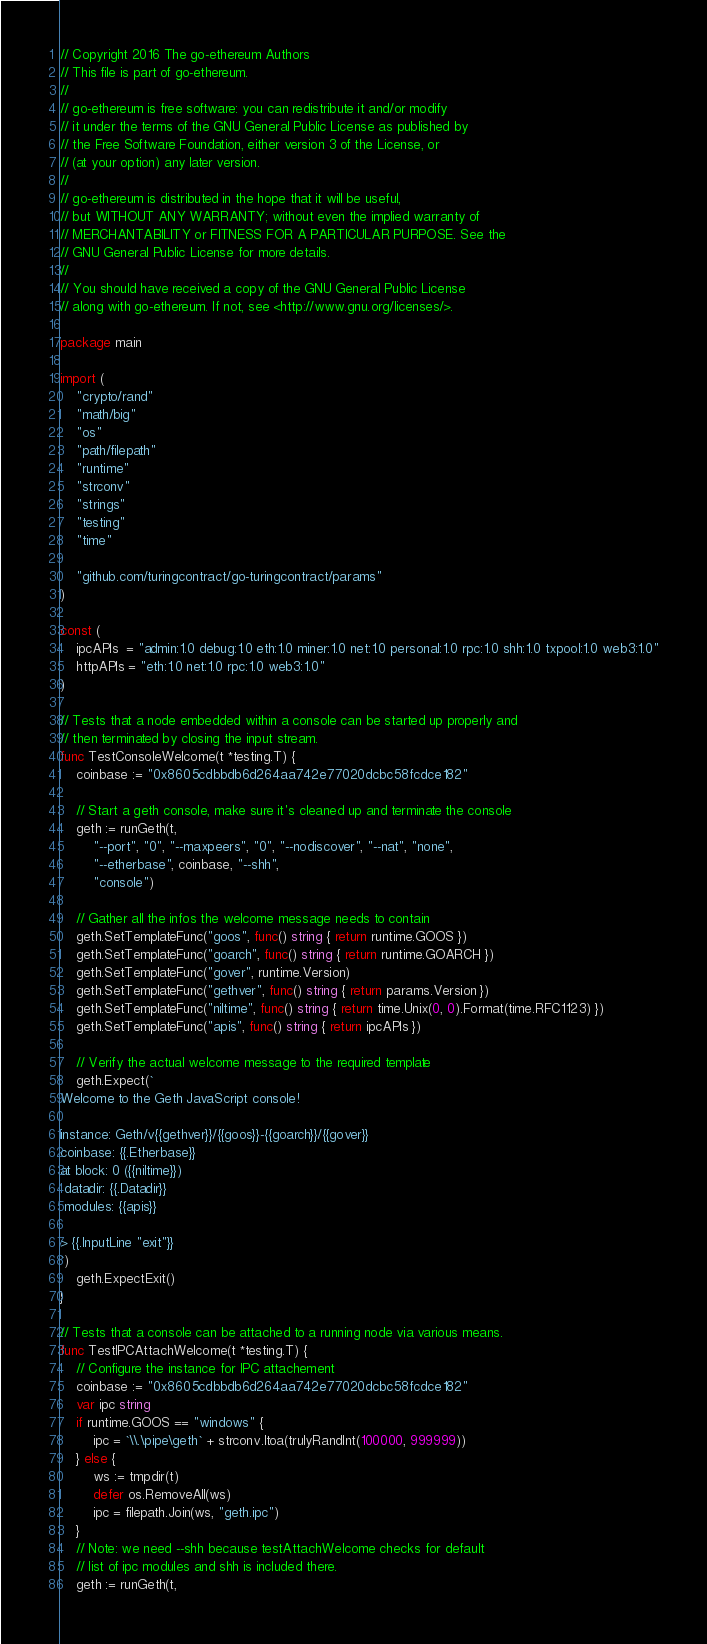Convert code to text. <code><loc_0><loc_0><loc_500><loc_500><_Go_>// Copyright 2016 The go-ethereum Authors
// This file is part of go-ethereum.
//
// go-ethereum is free software: you can redistribute it and/or modify
// it under the terms of the GNU General Public License as published by
// the Free Software Foundation, either version 3 of the License, or
// (at your option) any later version.
//
// go-ethereum is distributed in the hope that it will be useful,
// but WITHOUT ANY WARRANTY; without even the implied warranty of
// MERCHANTABILITY or FITNESS FOR A PARTICULAR PURPOSE. See the
// GNU General Public License for more details.
//
// You should have received a copy of the GNU General Public License
// along with go-ethereum. If not, see <http://www.gnu.org/licenses/>.

package main

import (
	"crypto/rand"
	"math/big"
	"os"
	"path/filepath"
	"runtime"
	"strconv"
	"strings"
	"testing"
	"time"

	"github.com/turingcontract/go-turingcontract/params"
)

const (
	ipcAPIs  = "admin:1.0 debug:1.0 eth:1.0 miner:1.0 net:1.0 personal:1.0 rpc:1.0 shh:1.0 txpool:1.0 web3:1.0"
	httpAPIs = "eth:1.0 net:1.0 rpc:1.0 web3:1.0"
)

// Tests that a node embedded within a console can be started up properly and
// then terminated by closing the input stream.
func TestConsoleWelcome(t *testing.T) {
	coinbase := "0x8605cdbbdb6d264aa742e77020dcbc58fcdce182"

	// Start a geth console, make sure it's cleaned up and terminate the console
	geth := runGeth(t,
		"--port", "0", "--maxpeers", "0", "--nodiscover", "--nat", "none",
		"--etherbase", coinbase, "--shh",
		"console")

	// Gather all the infos the welcome message needs to contain
	geth.SetTemplateFunc("goos", func() string { return runtime.GOOS })
	geth.SetTemplateFunc("goarch", func() string { return runtime.GOARCH })
	geth.SetTemplateFunc("gover", runtime.Version)
	geth.SetTemplateFunc("gethver", func() string { return params.Version })
	geth.SetTemplateFunc("niltime", func() string { return time.Unix(0, 0).Format(time.RFC1123) })
	geth.SetTemplateFunc("apis", func() string { return ipcAPIs })

	// Verify the actual welcome message to the required template
	geth.Expect(`
Welcome to the Geth JavaScript console!

instance: Geth/v{{gethver}}/{{goos}}-{{goarch}}/{{gover}}
coinbase: {{.Etherbase}}
at block: 0 ({{niltime}})
 datadir: {{.Datadir}}
 modules: {{apis}}

> {{.InputLine "exit"}}
`)
	geth.ExpectExit()
}

// Tests that a console can be attached to a running node via various means.
func TestIPCAttachWelcome(t *testing.T) {
	// Configure the instance for IPC attachement
	coinbase := "0x8605cdbbdb6d264aa742e77020dcbc58fcdce182"
	var ipc string
	if runtime.GOOS == "windows" {
		ipc = `\\.\pipe\geth` + strconv.Itoa(trulyRandInt(100000, 999999))
	} else {
		ws := tmpdir(t)
		defer os.RemoveAll(ws)
		ipc = filepath.Join(ws, "geth.ipc")
	}
	// Note: we need --shh because testAttachWelcome checks for default
	// list of ipc modules and shh is included there.
	geth := runGeth(t,</code> 